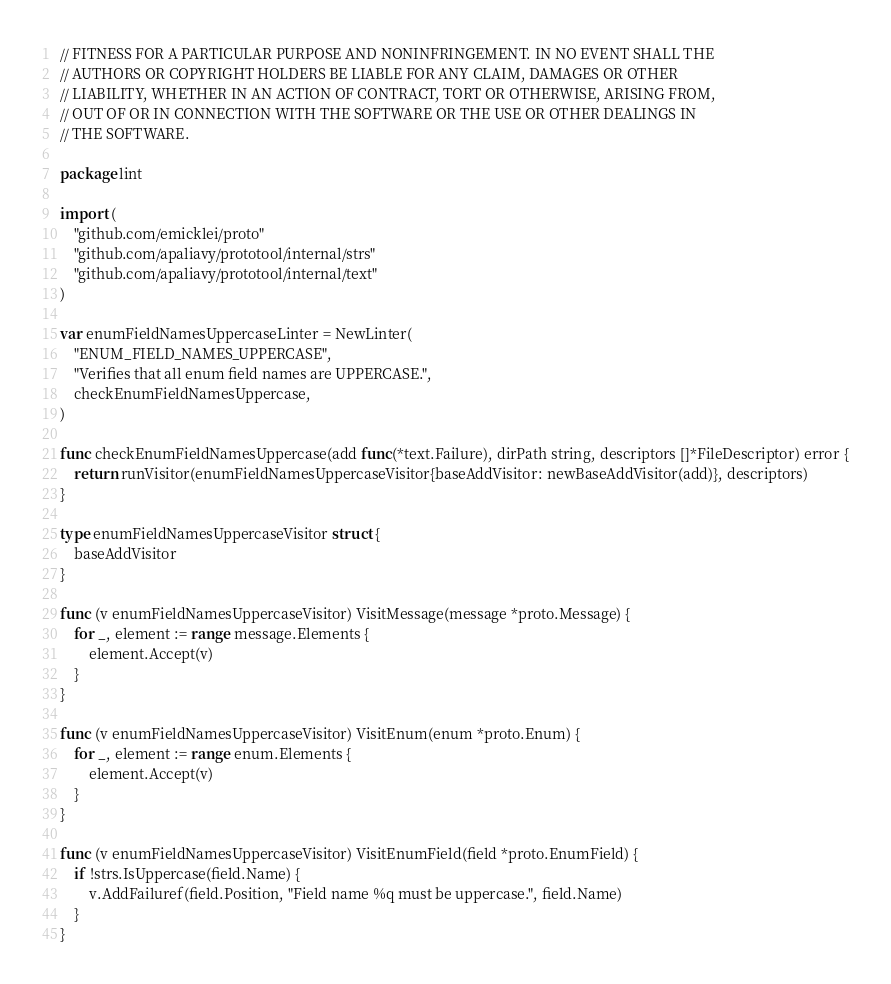Convert code to text. <code><loc_0><loc_0><loc_500><loc_500><_Go_>// FITNESS FOR A PARTICULAR PURPOSE AND NONINFRINGEMENT. IN NO EVENT SHALL THE
// AUTHORS OR COPYRIGHT HOLDERS BE LIABLE FOR ANY CLAIM, DAMAGES OR OTHER
// LIABILITY, WHETHER IN AN ACTION OF CONTRACT, TORT OR OTHERWISE, ARISING FROM,
// OUT OF OR IN CONNECTION WITH THE SOFTWARE OR THE USE OR OTHER DEALINGS IN
// THE SOFTWARE.

package lint

import (
	"github.com/emicklei/proto"
	"github.com/apaliavy/prototool/internal/strs"
	"github.com/apaliavy/prototool/internal/text"
)

var enumFieldNamesUppercaseLinter = NewLinter(
	"ENUM_FIELD_NAMES_UPPERCASE",
	"Verifies that all enum field names are UPPERCASE.",
	checkEnumFieldNamesUppercase,
)

func checkEnumFieldNamesUppercase(add func(*text.Failure), dirPath string, descriptors []*FileDescriptor) error {
	return runVisitor(enumFieldNamesUppercaseVisitor{baseAddVisitor: newBaseAddVisitor(add)}, descriptors)
}

type enumFieldNamesUppercaseVisitor struct {
	baseAddVisitor
}

func (v enumFieldNamesUppercaseVisitor) VisitMessage(message *proto.Message) {
	for _, element := range message.Elements {
		element.Accept(v)
	}
}

func (v enumFieldNamesUppercaseVisitor) VisitEnum(enum *proto.Enum) {
	for _, element := range enum.Elements {
		element.Accept(v)
	}
}

func (v enumFieldNamesUppercaseVisitor) VisitEnumField(field *proto.EnumField) {
	if !strs.IsUppercase(field.Name) {
		v.AddFailuref(field.Position, "Field name %q must be uppercase.", field.Name)
	}
}
</code> 